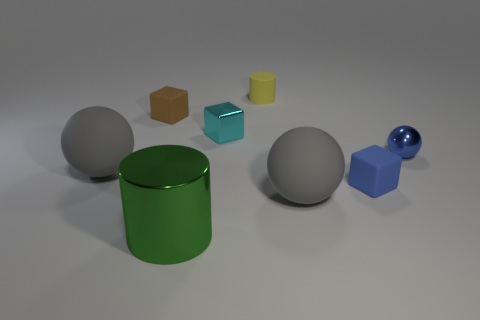Add 1 big green matte objects. How many objects exist? 9 Subtract all spheres. How many objects are left? 5 Subtract 0 purple blocks. How many objects are left? 8 Subtract all tiny blue shiny objects. Subtract all large gray blocks. How many objects are left? 7 Add 8 large cylinders. How many large cylinders are left? 9 Add 8 red shiny balls. How many red shiny balls exist? 8 